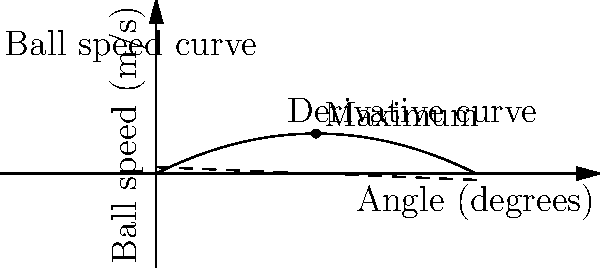As a tennis coach, you're helping your child optimize their serve. The graph shows the relationship between the angle of the racket at impact and the resulting ball speed. The solid curve represents the ball speed function $f(\theta) = 0.5\theta - 0.02\theta^2$, where $\theta$ is the angle in degrees and $f(\theta)$ is the ball speed in m/s. The dashed line represents the derivative of this function. At what angle should your child aim to hit the ball to achieve maximum speed, and what is this maximum speed? To find the maximum ball speed, we need to find the angle where the derivative of the function is zero. This is because the derivative represents the rate of change of the function, and at the maximum point, this rate of change will be zero.

1) The ball speed function is given by $f(\theta) = 0.5\theta - 0.02\theta^2$

2) The derivative of this function is $f'(\theta) = 0.5 - 0.04\theta$

3) To find the maximum, set $f'(\theta) = 0$:
   $0.5 - 0.04\theta = 0$

4) Solve for $\theta$:
   $0.04\theta = 0.5$
   $\theta = 0.5 / 0.04 = 12.5$ degrees

5) To find the maximum speed, plug this angle back into the original function:
   $f(12.5) = 0.5(12.5) - 0.02(12.5)^2$
   $= 6.25 - 0.02(156.25)$
   $= 6.25 - 3.125$
   $= 3.125$ m/s

Therefore, the maximum speed is achieved at an angle of 12.5 degrees, and the maximum speed is 3.125 m/s.
Answer: 12.5 degrees; 3.125 m/s 